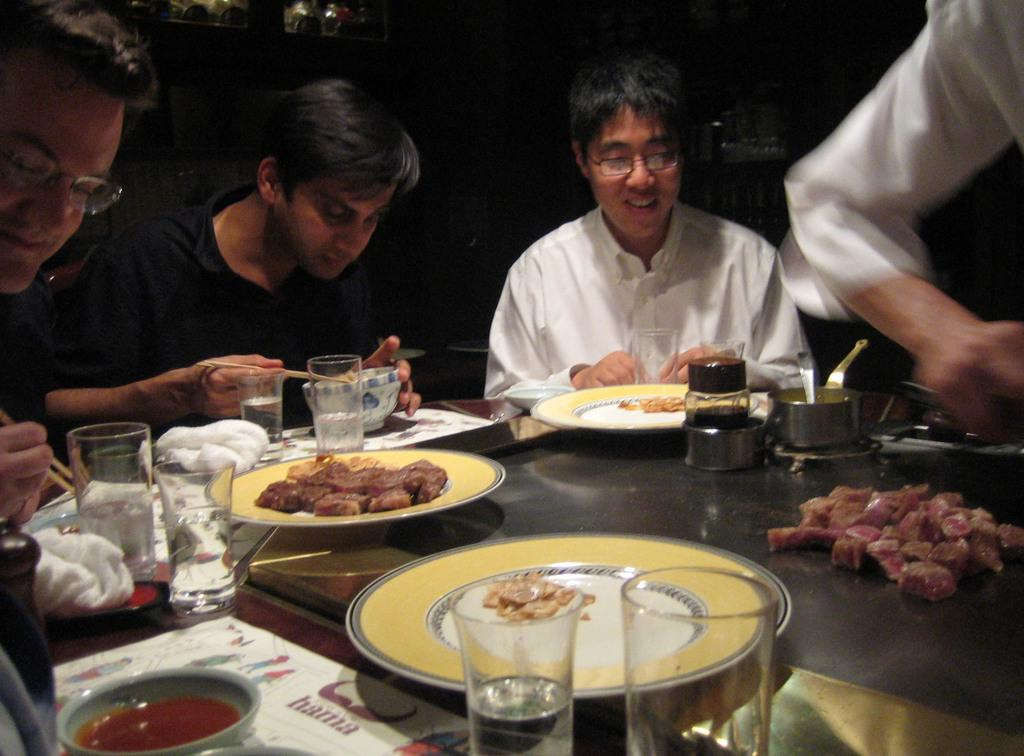How many people are in the image? There is a group of people in the image, but the exact number cannot be determined from the provided facts. What are the people doing in the image? The people are having food in the image. Where are the people sitting in the image? The people are sitting in front of a table in the image. What can be found on the table in the image? There are food items, glasses, and napkins on the table in the image. Can you tell me how many irons are on the table in the image? There is no mention of irons in the image; the table contains food items, glasses, and napkins. 